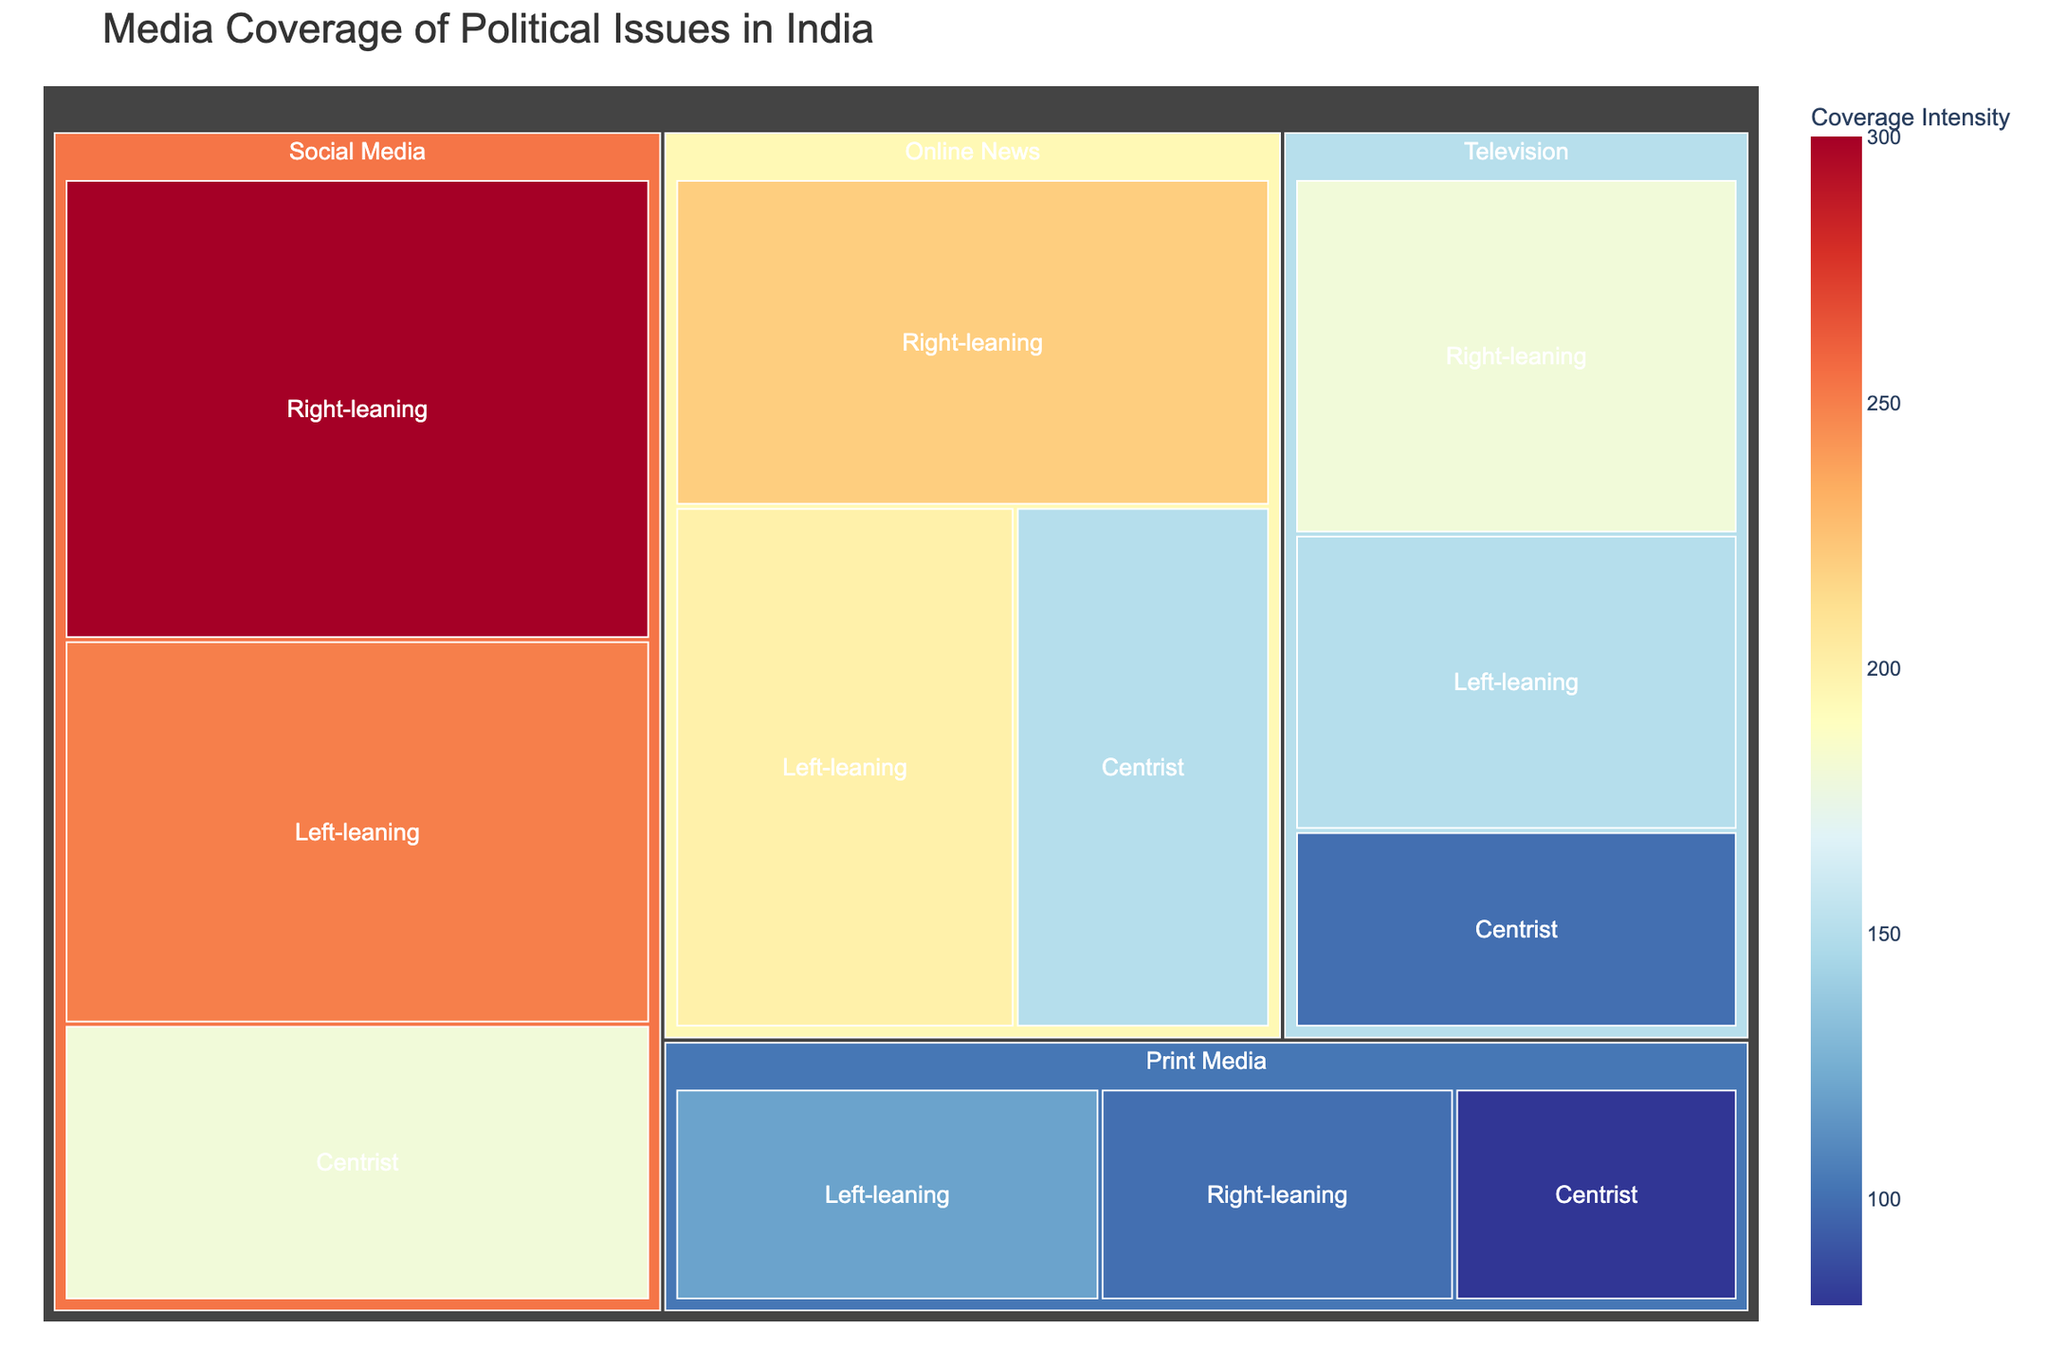What's the title of the Treemap? The Treemap's title is usually displayed prominently at the top. In this case, the title of the Treemap is "Media Coverage of Political Issues in India".
Answer: Media Coverage of Political Issues in India Which news outlet type and political leaning combination has the highest value in media coverage? To answer this, we need to compare the values of all combinations. "Social Media, Right-leaning" has the highest value, which is 300.
Answer: Social Media, Right-leaning What is the total media coverage value for Print Media? We sum the values for all political leanings under Print Media: 120 (Left-leaning) + 80 (Centrist) + 100 (Right-leaning). So, the total is 300.
Answer: 300 How does the coverage for Left-leaning Television compare to Right-leaning Television? The value for Left-leaning Television is 150, and for Right-leaning Television, it is 180. Right-leaning Television has a higher coverage.
Answer: Right-leaning Television has higher coverage What is the average media coverage value for Centrist outlets across all categories? We sum the Centrist values across all categories: 80 (Print Media) + 100 (Television) + 150 (Online News) + 180 (Social Media), giving a total of 510. Dividing by 4 gives an average of 127.5.
Answer: 127.5 Which category that appears to have the highest variance in media coverage values? To determine variance, we look for the category with the widest distribution of values. Social Media values range from 180 to 300, showing a high variance.
Answer: Social Media What percentage of the total media coverage does Online News Right-leaning contribute? Total media coverage is the sum of all values: 1930. Online News Right-leaning is 220. The percentage is (220/1930) * 100, which is approximately 11.4%.
Answer: 11.4% What is the combined media coverage value for Left-leaning outlets across all categories? Summing the values for Left-leaning: 120 (Print Media) + 150 (Television) + 200 (Online News) + 250 (Social Media), the total is 720.
Answer: 720 Among all categories, which political leaning has the lowest total media coverage? We need to sum the values for each political leaning: Left-leaning (120 + 150 + 200 + 250 = 720), Centrist (80 + 100 + 150 + 180 = 510), Right-leaning (100 + 180 + 220 + 300 = 800). Therefore, Centrist has the lowest total coverage.
Answer: Centrist What is the sum of media coverage values for Online News and Social Media categories? We add all values from Online News and Social Media: 200 + 150 + 220 + 250 + 180 + 300 = 1300.
Answer: 1300 